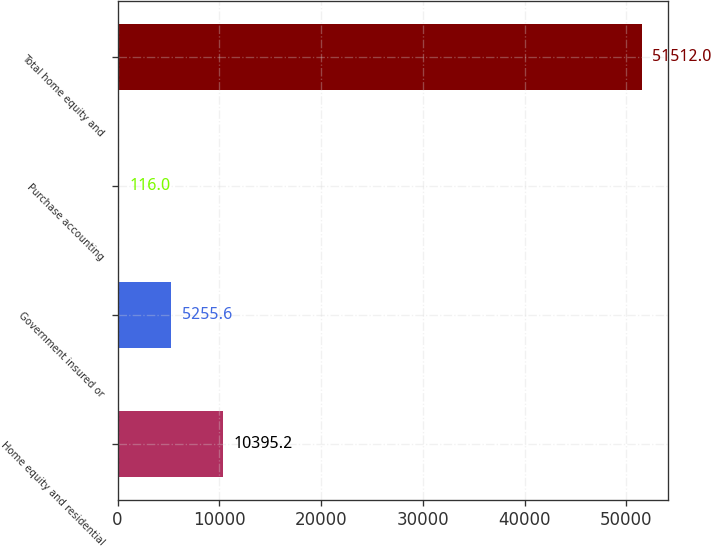Convert chart. <chart><loc_0><loc_0><loc_500><loc_500><bar_chart><fcel>Home equity and residential<fcel>Government insured or<fcel>Purchase accounting<fcel>Total home equity and<nl><fcel>10395.2<fcel>5255.6<fcel>116<fcel>51512<nl></chart> 